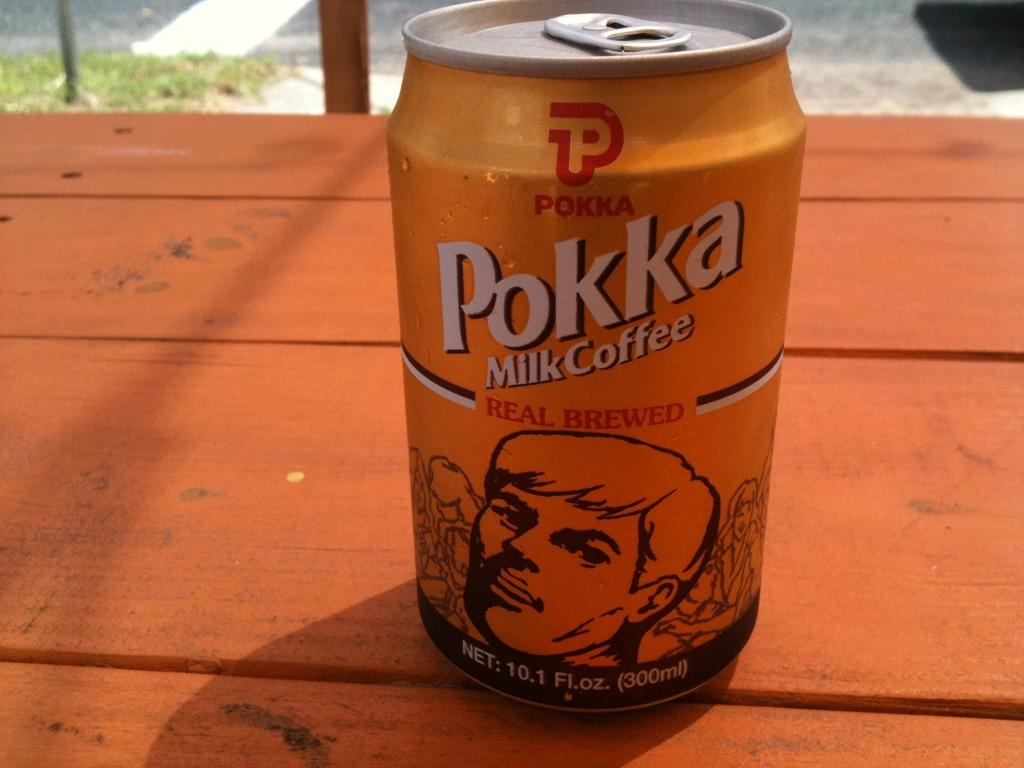<image>
Give a short and clear explanation of the subsequent image. The drink in the can is Pokka Milk Coffee 